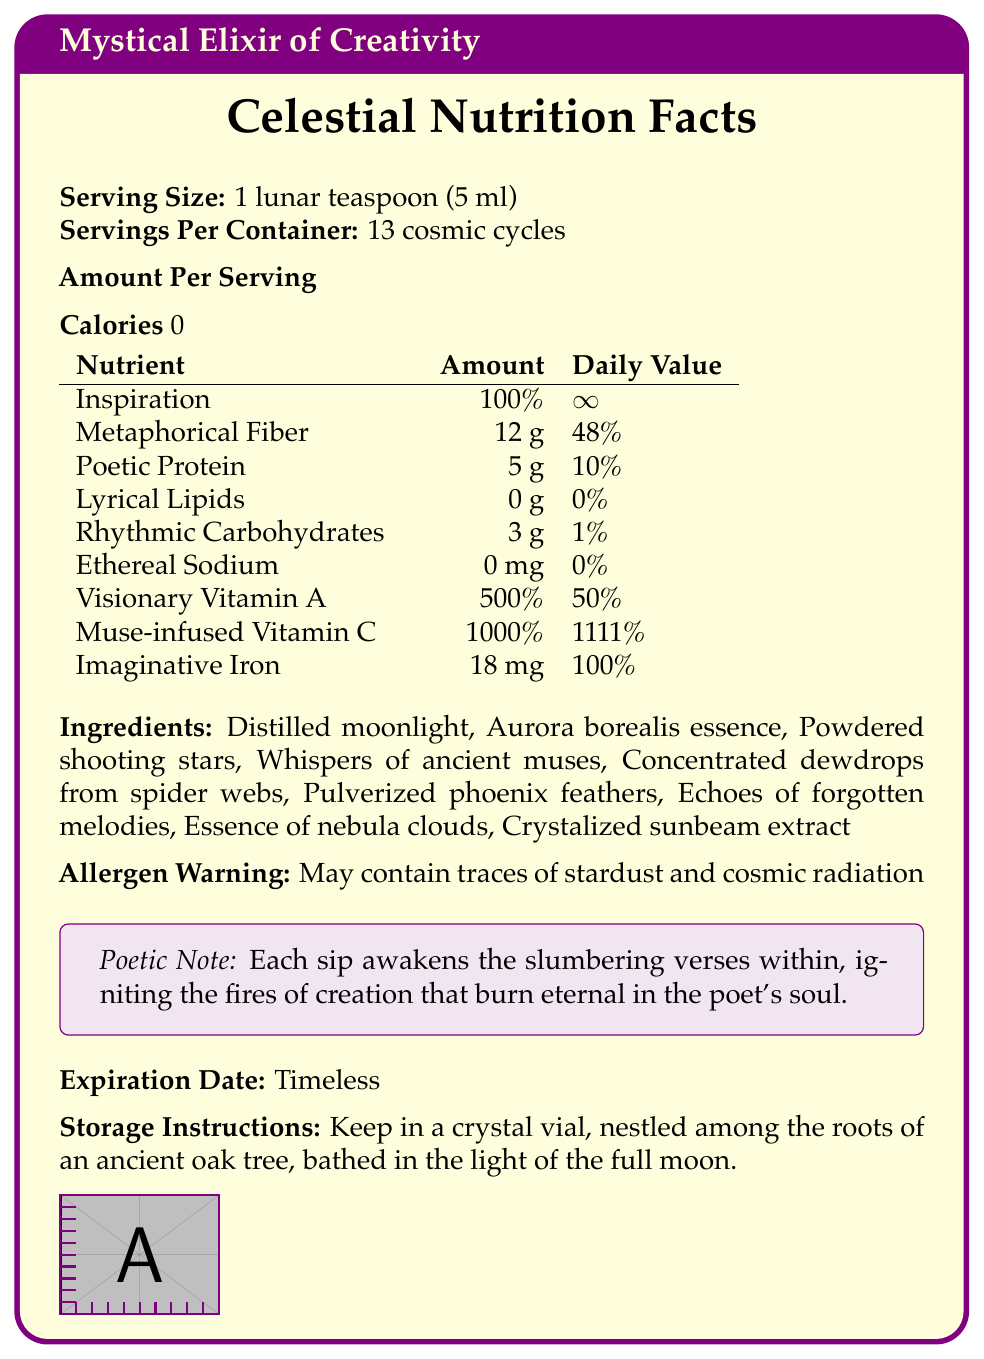what is the serving size? The serving size is clearly stated under "Serving Size."
Answer: 1 lunar teaspoon (5 ml) how many servings are in one container? The number of servings per container is indicated as "13 cosmic cycles."
Answer: 13 cosmic cycles how many calories are there per serving? According to the "Amount Per Serving" section, the calories per serving are 0.
Answer: 0 how much Poetic Protein is in one serving? The table lists "Poetic Protein" as having 5 g per serving.
Answer: 5 g what is the daily value of Imaginative Iron in one serving? The daily value for Imaginative Iron is listed as 100%.
Answer: 100% which ingredient is not listed in the ingredients section? A. Crystalized sunbeam extract B. Lyrical Lipids C. Essence of nebula clouds Lyrical Lipids is part of the nutritional facts section, not the ingredients.
Answer: B what is the daily value percentage for Visionary Vitamin A? A. 50% B. 100% C. 500% D. 1111% The daily value percentage for Visionary Vitamin A is given as 50%.
Answer: A does the elixir contain any ethereal sodium? The table indicates that Ethereal Sodium is 0 mg per serving, thus it contains no Ethereal Sodium.
Answer: No describe the storage instructions for the elixir. The document provides specific storage instructions for the mystical elixir.
Answer: Keep in a crystal vial, nestled among the roots of an ancient oak tree, bathed in the light of the full moon. are there any allergens present in the elixir? The allergen warning states that it may contain traces of stardust and cosmic radiation.
Answer: Yes what effect does the elixir have on a consumer? This poetic note is provided toward the end of the document.
Answer: Each sip awakens the slumbering verses within, igniting the fires of creation that burn eternal in the poet's soul. what is the expiration date of the elixir? The expiration date listed for the elixir is "Timeless."
Answer: Timeless can one determine if the elixir can increase physical strength? The document provides no information on whether the elixir increases physical strength. It focuses on creativity and poetic metaphors.
Answer: Cannot be determined 